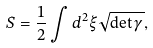Convert formula to latex. <formula><loc_0><loc_0><loc_500><loc_500>S = \frac { 1 } { 2 } \int d ^ { 2 } \xi \sqrt { \det \gamma } ,</formula> 